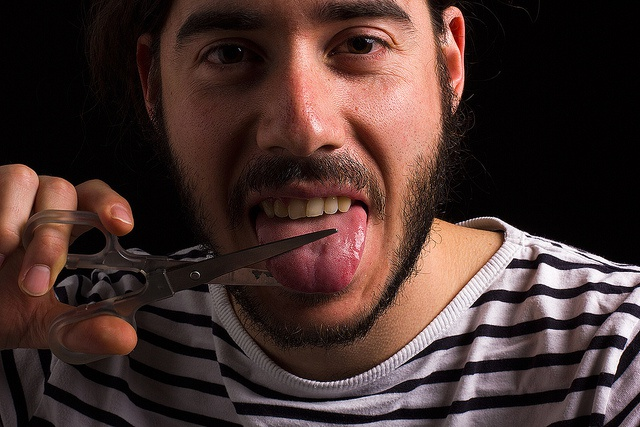Describe the objects in this image and their specific colors. I can see people in black, maroon, salmon, and brown tones and scissors in black, maroon, and brown tones in this image. 